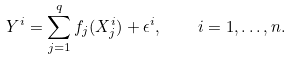<formula> <loc_0><loc_0><loc_500><loc_500>Y ^ { i } = \sum _ { j = 1 } ^ { q } f _ { j } ( X ^ { i } _ { j } ) + \epsilon ^ { i } , \quad i = 1 , \dots , n .</formula> 